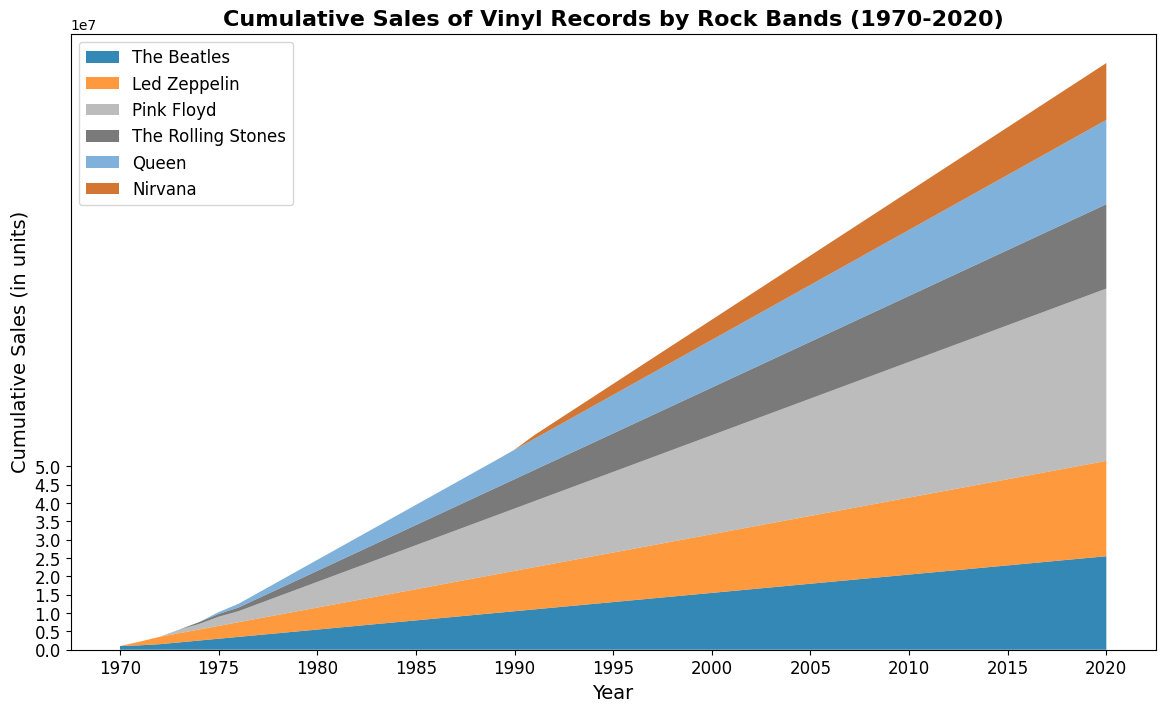What's the total cumulative sales of all bands in 1980? To find the total cumulative sales of all bands in 1980: sum the individual sales: (5500000 + 6000000 + 7000000 + 3000000 + 3000000 + 0). This totals to 24500000 units.
Answer: 24500000 Which band had the highest cumulative sales in 2020? Look at each band's cumulative sales in 2020 and compare: The Beatles at 25500000, Led Zeppelin at 26000000, Pink Floyd at 47000000, The Rolling Stones at 23000000, Queen at 23000000, Nirvana at 15500000. Pink Floyd had the highest cumulative sales.
Answer: Pink Floyd How do the cumulative sales of The Beatles and Led Zeppelin compare in 1975? Compare the heights at 1975: The Beatles have 3000000, Led Zeppelin has 3500000. Led Zeppelin has higher cumulative sales.
Answer: Led Zeppelin When did Pink Floyd surpass 10 million cumulative sales? Find the year where Pink Floyd's cumulative sales first exceeds 10 million: Looking year by year, 1983 shows Pink Floyd's cumulative sales reaching 10000000.
Answer: 1983 What is the difference in cumulative sales between The Rolling Stones and Nirvana in 1994? Subtract Nirvana's 1994 sales from The Rolling Stones': 10000000 - 2500000 = 7500000.
Answer: 7500000 Which bands reached 20 million cumulative sales first and last? Check year by year visually from the left side of the area chart (1970 onward), first: The Beatles reached 20 million first in 1988. Last: Nirvana in 2009.
Answer: The Beatles, Nirvana What is the average cumulative sales of Queen over the years 1990 to 2000? (8000000 + 8500000 + 9000000 + 9500000 + 10000000 + 10500000 + 11000000 + 11500000 + 12000000 + 12500000 + 13000000)/11 = 10500000 units.
Answer: 10500000 By how much did the cumulative sales of The Beatles increase from 1980 to 1990? Subtract 1980 sales from 1990 sales for The Beatles: 10500000 - 5500000 = 5000000.
Answer: 5000000 Which band had the least cumulative sales in 2010? Look at each band's cumulative sales in 2010: The Beatles 20500000, Led Zeppelin 21000000, Pink Floyd 37000000, The Rolling Stones 18000000, Queen 18000000, Nirvana 10500000. Nirvana had the least cumulative sales.
Answer: Nirvana 